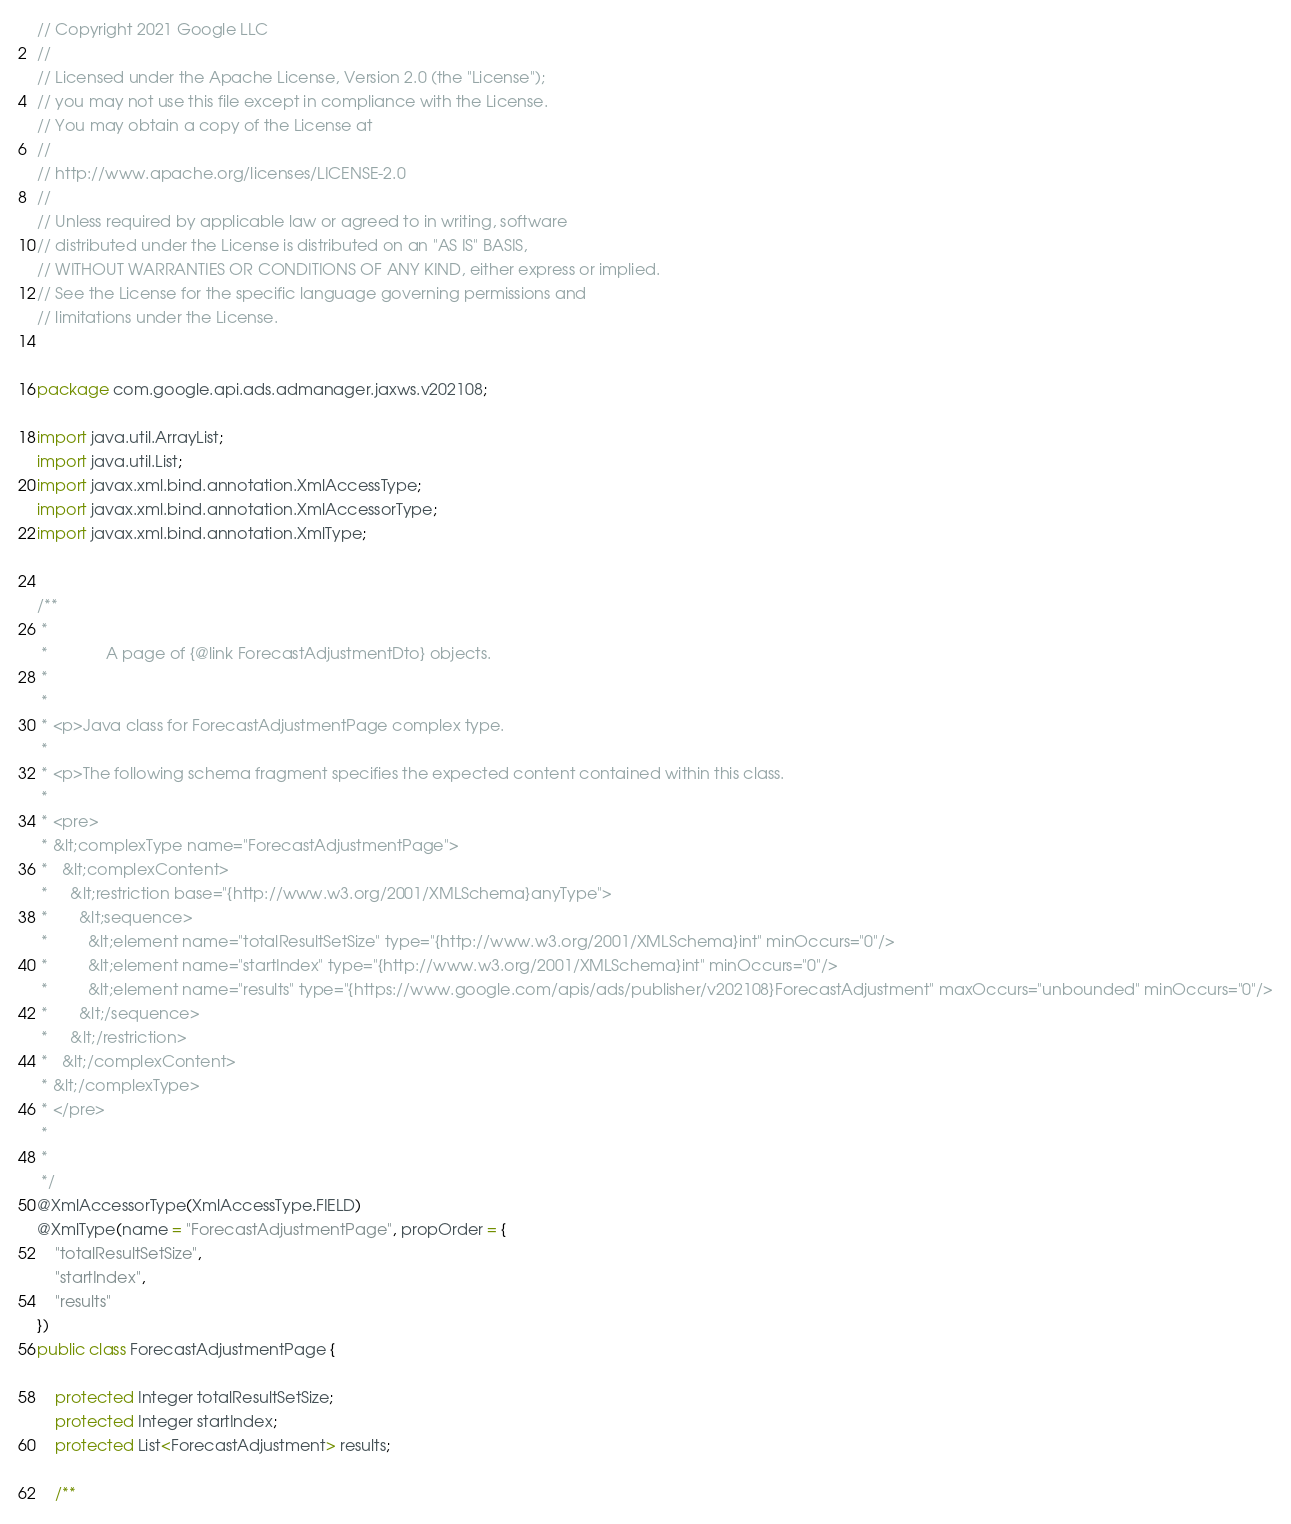Convert code to text. <code><loc_0><loc_0><loc_500><loc_500><_Java_>// Copyright 2021 Google LLC
//
// Licensed under the Apache License, Version 2.0 (the "License");
// you may not use this file except in compliance with the License.
// You may obtain a copy of the License at
//
// http://www.apache.org/licenses/LICENSE-2.0
//
// Unless required by applicable law or agreed to in writing, software
// distributed under the License is distributed on an "AS IS" BASIS,
// WITHOUT WARRANTIES OR CONDITIONS OF ANY KIND, either express or implied.
// See the License for the specific language governing permissions and
// limitations under the License.


package com.google.api.ads.admanager.jaxws.v202108;

import java.util.ArrayList;
import java.util.List;
import javax.xml.bind.annotation.XmlAccessType;
import javax.xml.bind.annotation.XmlAccessorType;
import javax.xml.bind.annotation.XmlType;


/**
 * 
 *             A page of {@link ForecastAdjustmentDto} objects.
 *           
 * 
 * <p>Java class for ForecastAdjustmentPage complex type.
 * 
 * <p>The following schema fragment specifies the expected content contained within this class.
 * 
 * <pre>
 * &lt;complexType name="ForecastAdjustmentPage">
 *   &lt;complexContent>
 *     &lt;restriction base="{http://www.w3.org/2001/XMLSchema}anyType">
 *       &lt;sequence>
 *         &lt;element name="totalResultSetSize" type="{http://www.w3.org/2001/XMLSchema}int" minOccurs="0"/>
 *         &lt;element name="startIndex" type="{http://www.w3.org/2001/XMLSchema}int" minOccurs="0"/>
 *         &lt;element name="results" type="{https://www.google.com/apis/ads/publisher/v202108}ForecastAdjustment" maxOccurs="unbounded" minOccurs="0"/>
 *       &lt;/sequence>
 *     &lt;/restriction>
 *   &lt;/complexContent>
 * &lt;/complexType>
 * </pre>
 * 
 * 
 */
@XmlAccessorType(XmlAccessType.FIELD)
@XmlType(name = "ForecastAdjustmentPage", propOrder = {
    "totalResultSetSize",
    "startIndex",
    "results"
})
public class ForecastAdjustmentPage {

    protected Integer totalResultSetSize;
    protected Integer startIndex;
    protected List<ForecastAdjustment> results;

    /**</code> 